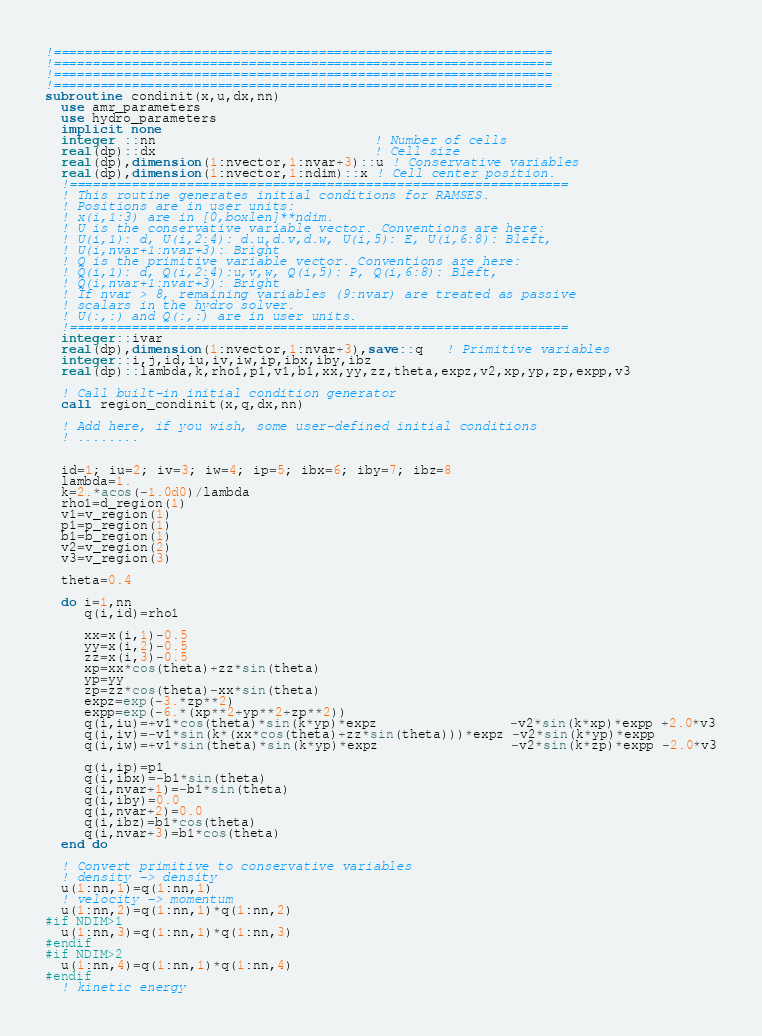Convert code to text. <code><loc_0><loc_0><loc_500><loc_500><_FORTRAN_>!================================================================
!================================================================
!================================================================
!================================================================
subroutine condinit(x,u,dx,nn)
  use amr_parameters
  use hydro_parameters
  implicit none
  integer ::nn                            ! Number of cells
  real(dp)::dx                            ! Cell size
  real(dp),dimension(1:nvector,1:nvar+3)::u ! Conservative variables
  real(dp),dimension(1:nvector,1:ndim)::x ! Cell center position.
  !================================================================
  ! This routine generates initial conditions for RAMSES.
  ! Positions are in user units:
  ! x(i,1:3) are in [0,boxlen]**ndim.
  ! U is the conservative variable vector. Conventions are here:
  ! U(i,1): d, U(i,2:4): d.u,d.v,d.w, U(i,5): E, U(i,6:8): Bleft, 
  ! U(i,nvar+1:nvar+3): Bright
  ! Q is the primitive variable vector. Conventions are here:
  ! Q(i,1): d, Q(i,2:4):u,v,w, Q(i,5): P, Q(i,6:8): Bleft, 
  ! Q(i,nvar+1:nvar+3): Bright
  ! If nvar > 8, remaining variables (9:nvar) are treated as passive
  ! scalars in the hydro solver.
  ! U(:,:) and Q(:,:) are in user units.
  !================================================================
  integer::ivar
  real(dp),dimension(1:nvector,1:nvar+3),save::q   ! Primitive variables
  integer::i,j,id,iu,iv,iw,ip,ibx,iby,ibz
  real(dp)::lambda,k,rho1,p1,v1,b1,xx,yy,zz,theta,expz,v2,xp,yp,zp,expp,v3

  ! Call built-in initial condition generator
  call region_condinit(x,q,dx,nn)

  ! Add here, if you wish, some user-defined initial conditions
  ! ........

  
  id=1; iu=2; iv=3; iw=4; ip=5; ibx=6; iby=7; ibz=8
  lambda=1.
  k=2.*acos(-1.0d0)/lambda
  rho1=d_region(1)
  v1=v_region(1)
  p1=p_region(1)
  b1=b_region(1)
  v2=v_region(2)
  v3=v_region(3)
  
  theta=0.4

  do i=1,nn
     q(i,id)=rho1

     xx=x(i,1)-0.5
     yy=x(i,2)-0.5
     zz=x(i,3)-0.5
     xp=xx*cos(theta)+zz*sin(theta)
     yp=yy
     zp=zz*cos(theta)-xx*sin(theta)
     expz=exp(-3.*zp**2)
     expp=exp(-6.*(xp**2+yp**2+zp**2))
     q(i,iu)=+v1*cos(theta)*sin(k*yp)*expz                 -v2*sin(k*xp)*expp +2.0*v3
     q(i,iv)=-v1*sin(k*(xx*cos(theta)+zz*sin(theta)))*expz -v2*sin(k*yp)*expp 
     q(i,iw)=+v1*sin(theta)*sin(k*yp)*expz                 -v2*sin(k*zp)*expp -2.0*v3

     q(i,ip)=p1
     q(i,ibx)=-b1*sin(theta)
     q(i,nvar+1)=-b1*sin(theta)
     q(i,iby)=0.0
     q(i,nvar+2)=0.0
     q(i,ibz)=b1*cos(theta)
     q(i,nvar+3)=b1*cos(theta)
  end do

  ! Convert primitive to conservative variables
  ! density -> density
  u(1:nn,1)=q(1:nn,1)
  ! velocity -> momentum
  u(1:nn,2)=q(1:nn,1)*q(1:nn,2)
#if NDIM>1
  u(1:nn,3)=q(1:nn,1)*q(1:nn,3)
#endif
#if NDIM>2
  u(1:nn,4)=q(1:nn,1)*q(1:nn,4)
#endif
  ! kinetic energy</code> 